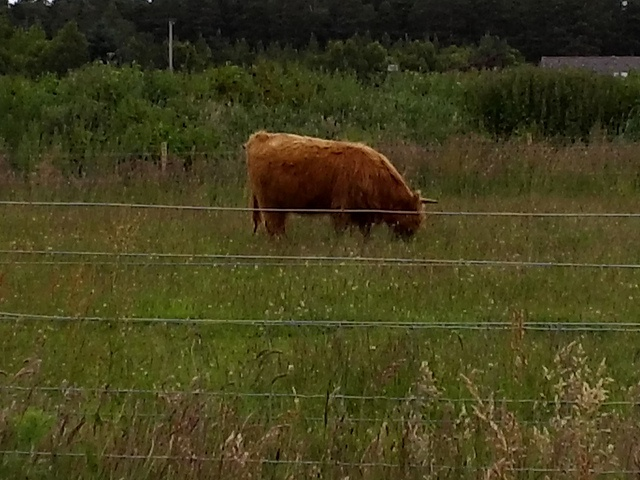Describe the objects in this image and their specific colors. I can see a cow in black, maroon, and brown tones in this image. 